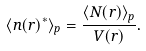<formula> <loc_0><loc_0><loc_500><loc_500>\langle n ( r ) ^ { * } \rangle _ { p } = \frac { \langle { N ( r ) } \rangle _ { p } } { V ( r ) } .</formula> 